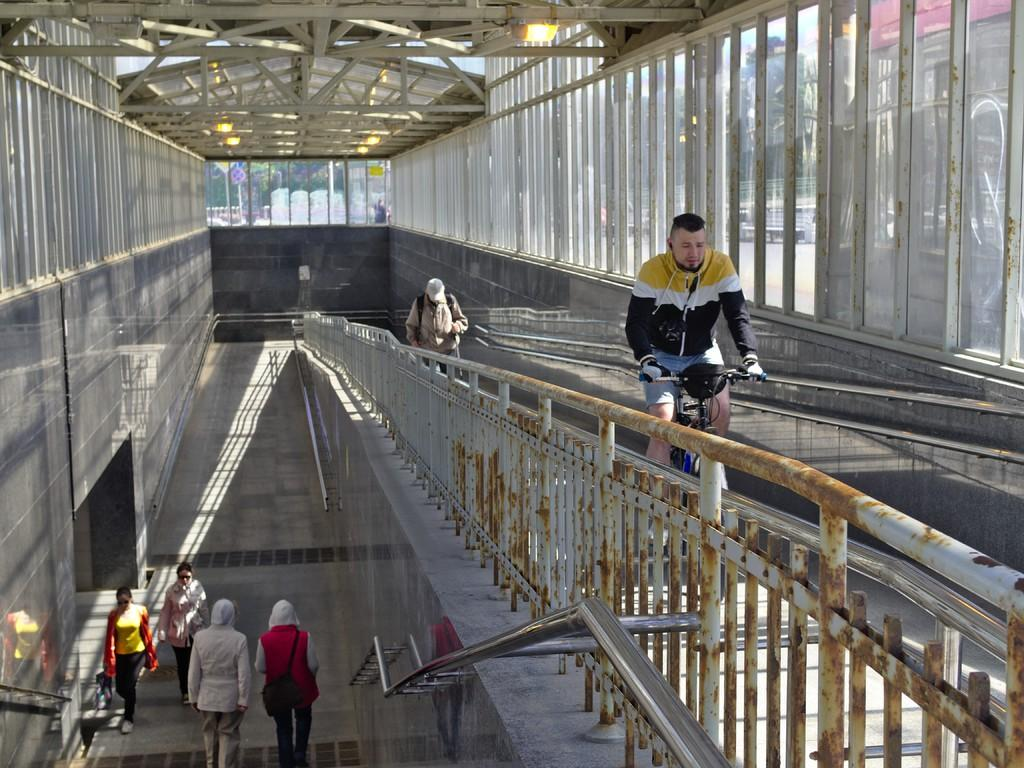How many people are present in the image? There are five people in the image. What are the people in the image doing? The people are walking on the floor. Is there any mode of transportation visible in the image? Yes, there is a man riding a bicycle in the image. What type of boundary can be seen in the image? There is no boundary visible in the image. What process is being carried out by the people in the image? The facts provided do not specify any particular process being carried out by the people in the image. 